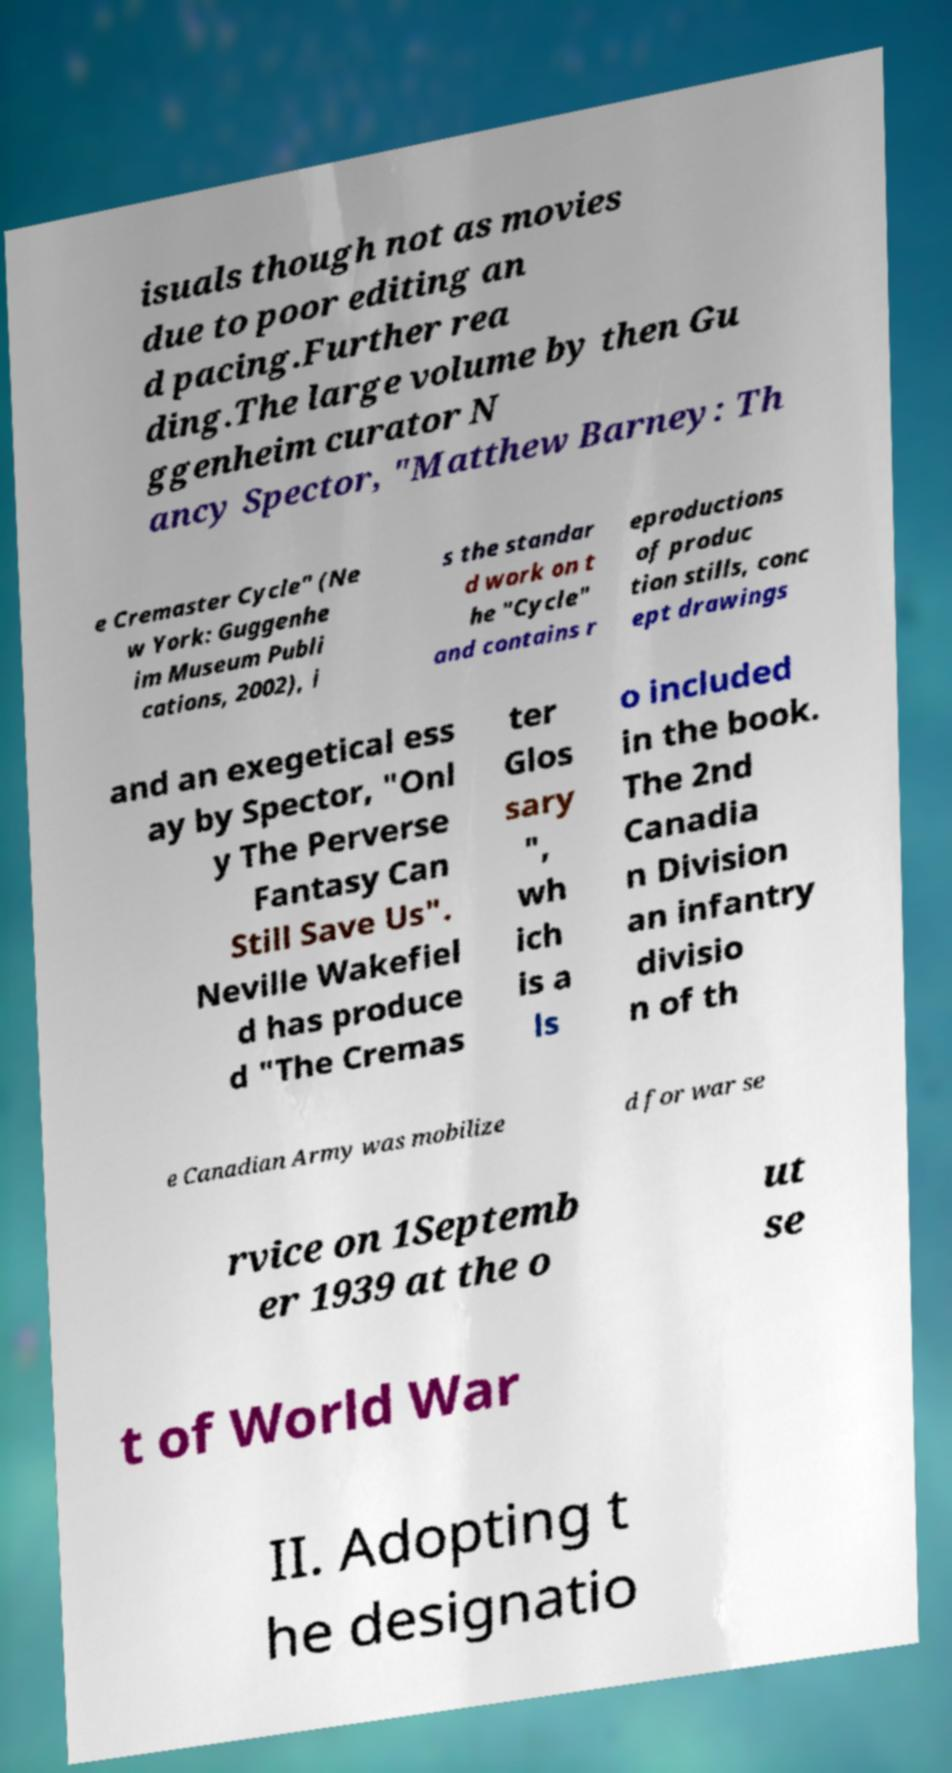Can you read and provide the text displayed in the image?This photo seems to have some interesting text. Can you extract and type it out for me? isuals though not as movies due to poor editing an d pacing.Further rea ding.The large volume by then Gu ggenheim curator N ancy Spector, "Matthew Barney: Th e Cremaster Cycle" (Ne w York: Guggenhe im Museum Publi cations, 2002), i s the standar d work on t he "Cycle" and contains r eproductions of produc tion stills, conc ept drawings and an exegetical ess ay by Spector, "Onl y The Perverse Fantasy Can Still Save Us". Neville Wakefiel d has produce d "The Cremas ter Glos sary ", wh ich is a ls o included in the book. The 2nd Canadia n Division an infantry divisio n of th e Canadian Army was mobilize d for war se rvice on 1Septemb er 1939 at the o ut se t of World War II. Adopting t he designatio 